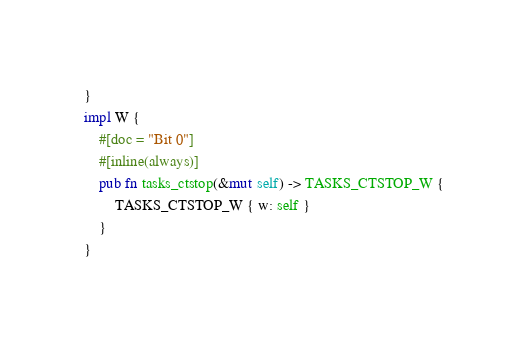Convert code to text. <code><loc_0><loc_0><loc_500><loc_500><_Rust_>}
impl W {
    #[doc = "Bit 0"]
    #[inline(always)]
    pub fn tasks_ctstop(&mut self) -> TASKS_CTSTOP_W {
        TASKS_CTSTOP_W { w: self }
    }
}
</code> 